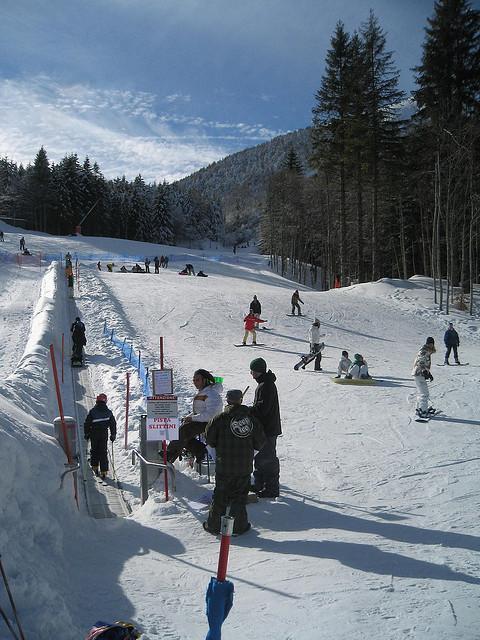What level of skier is this part of the hill designed for?
From the following four choices, select the correct answer to address the question.
Options: Advanced, expert, intermediate, beginner. Beginner. 